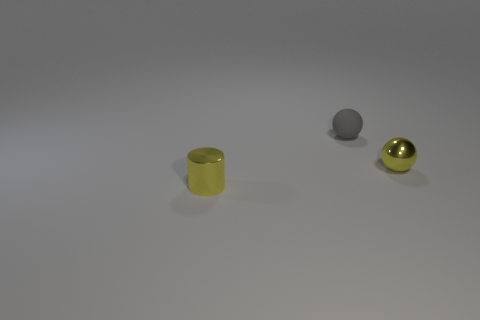What is the size of the yellow metal thing on the right side of the matte object?
Make the answer very short. Small. The metallic object that is behind the thing that is in front of the tiny metallic thing right of the metal cylinder is what color?
Offer a terse response. Yellow. The tiny thing in front of the small sphere in front of the gray object is what color?
Your answer should be compact. Yellow. Are there more yellow things that are in front of the yellow metal cylinder than matte objects that are in front of the gray rubber thing?
Make the answer very short. No. Do the yellow object behind the tiny yellow cylinder and the small ball that is to the left of the metallic sphere have the same material?
Keep it short and to the point. No. There is a tiny gray sphere; are there any gray rubber things in front of it?
Make the answer very short. No. How many yellow objects are either balls or matte balls?
Keep it short and to the point. 1. Are the small gray ball and the tiny yellow object left of the tiny gray rubber ball made of the same material?
Your answer should be compact. No. The other yellow object that is the same shape as the tiny matte thing is what size?
Provide a short and direct response. Small. What material is the yellow cylinder?
Give a very brief answer. Metal. 